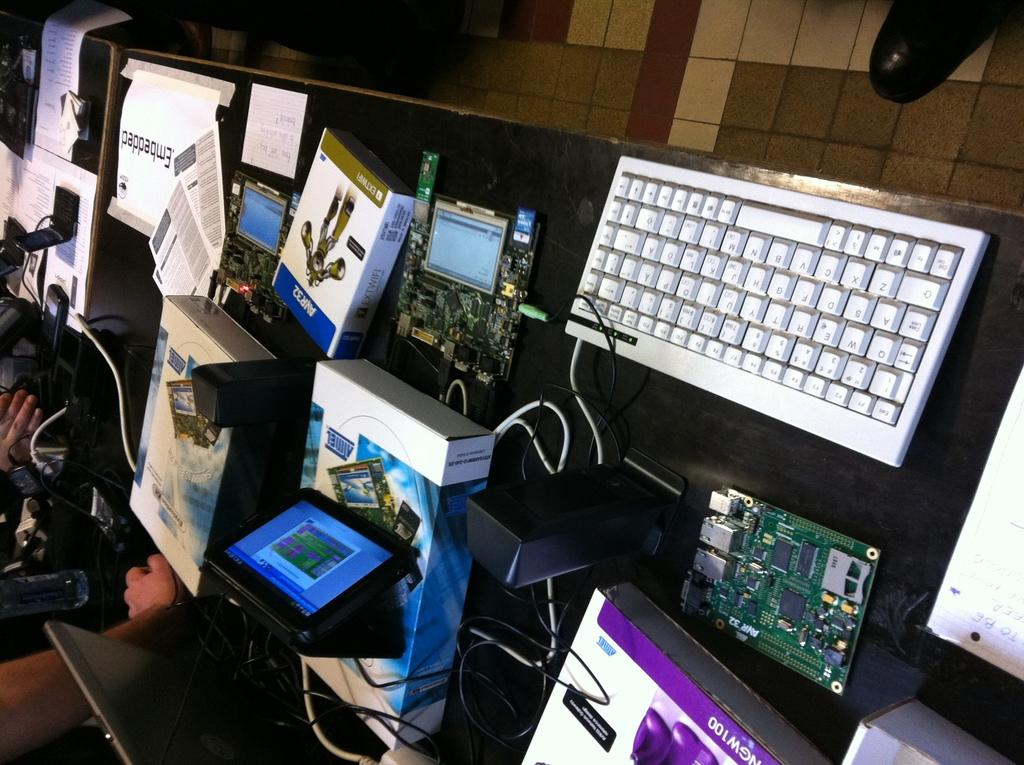<image>
Share a concise interpretation of the image provided. a keyboard in front of boxes with one labeled almel 